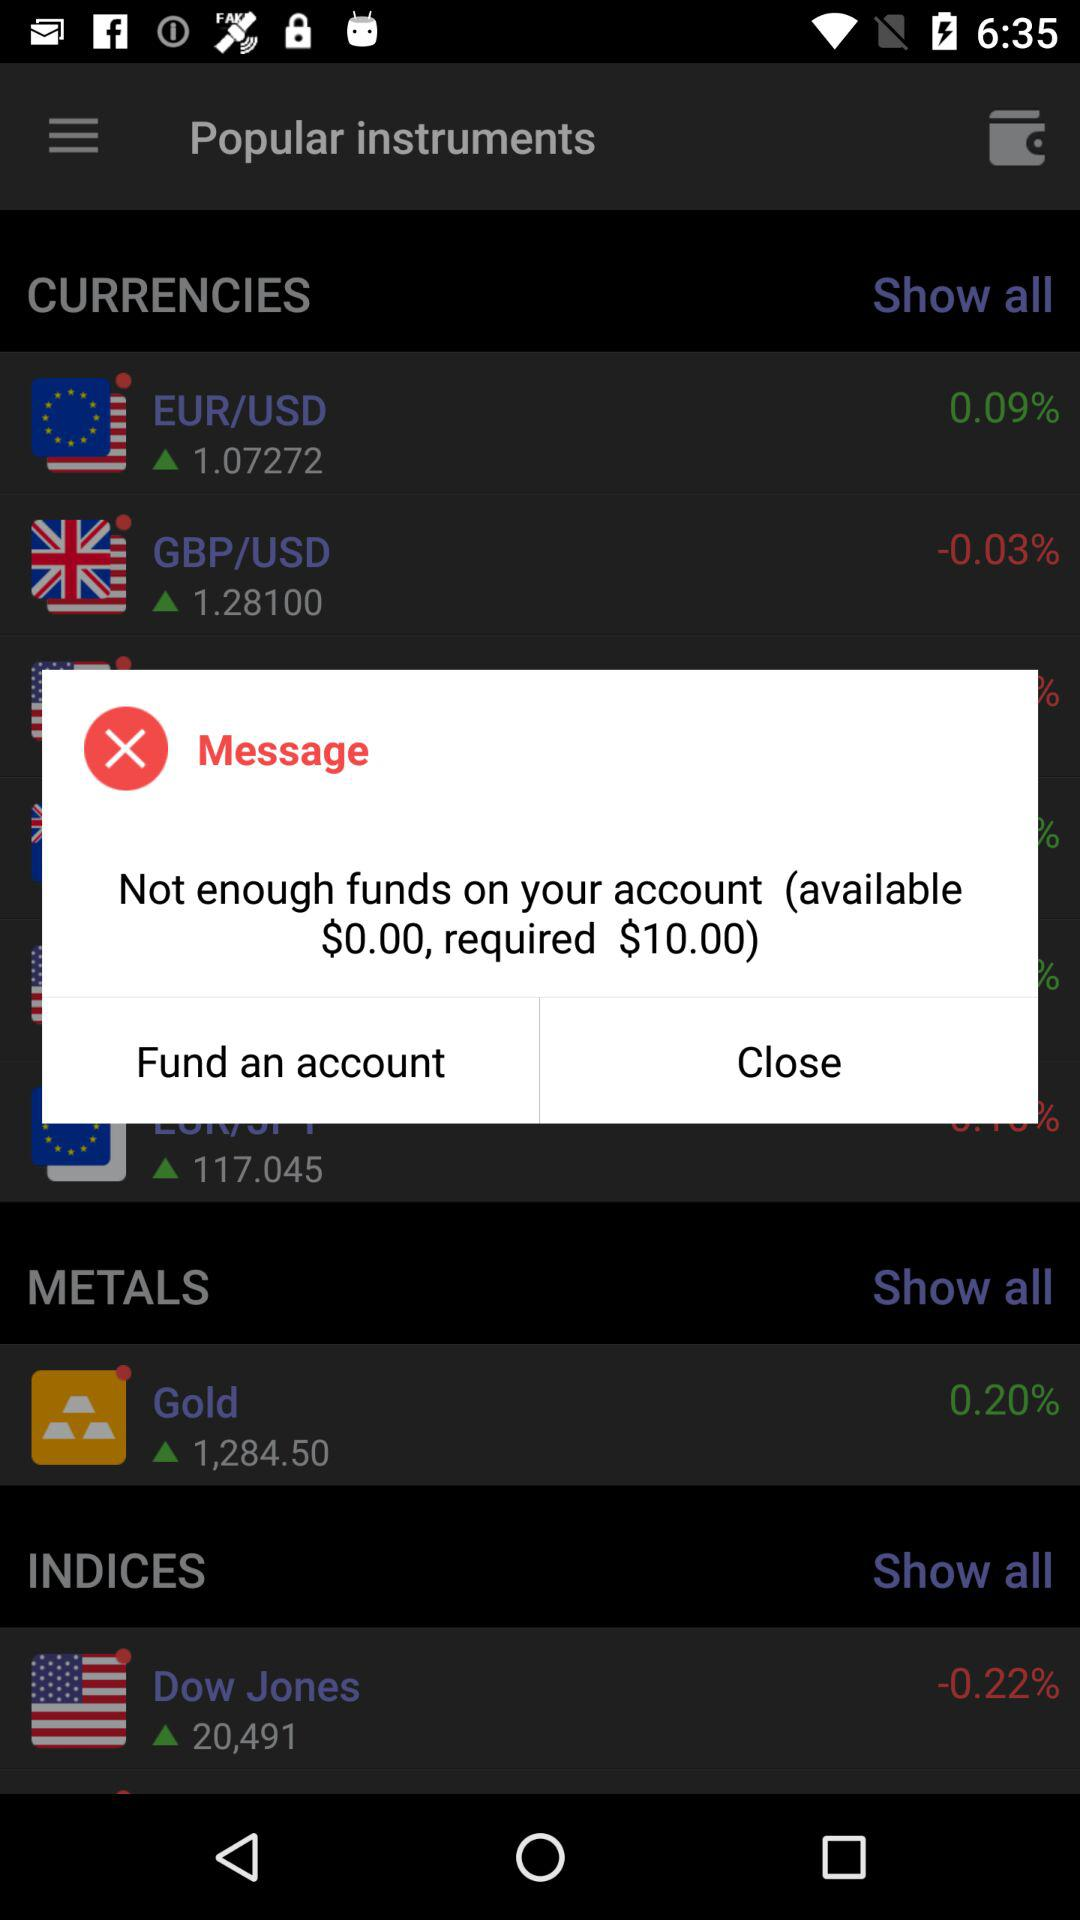How much more money is required to fund the account?
Answer the question using a single word or phrase. $10.00 